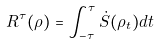<formula> <loc_0><loc_0><loc_500><loc_500>R ^ { \tau } ( \rho ) = \int _ { - \tau } ^ { \tau } \dot { S } ( \rho _ { t } ) d t</formula> 